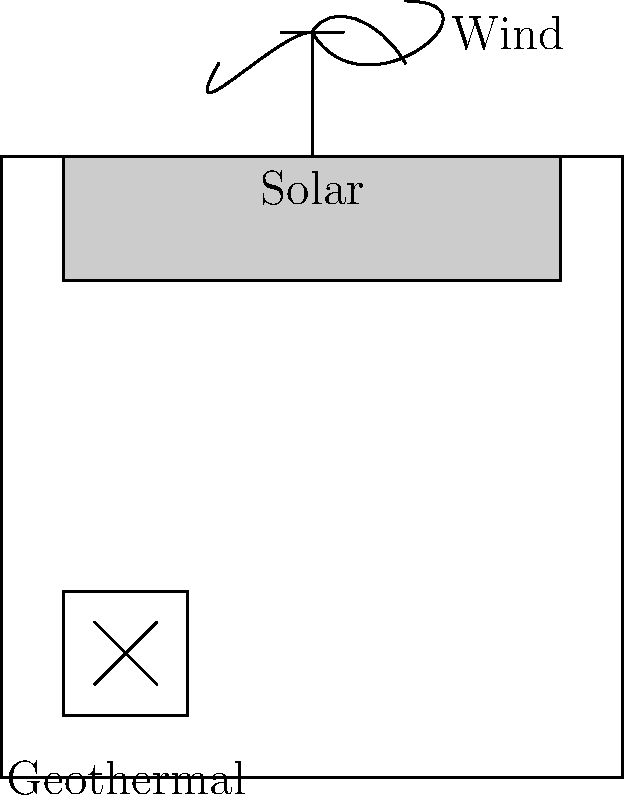As an environmentalist concerned with local energy efficiency, which renewable energy installation shown in the schematic drawing of a building would likely have the highest energy output in an urban setting, and why? To answer this question, we need to consider the characteristics of each renewable energy source shown in the schematic and their typical performance in urban environments:

1. Solar panels:
   - Positioned on the roof, maximizing exposure to sunlight
   - Effective in urban areas with minimal shading from other buildings
   - Consistent energy production during daylight hours
   - Efficiency typically ranges from 15-22% for commercial panels

2. Wind turbine:
   - Mounted on top of the building
   - Urban areas often have lower wind speeds and more turbulent airflow due to surrounding structures
   - Efficiency can vary greatly depending on wind conditions, typically 30-45% for small turbines

3. Geothermal system:
   - Installed underground, likely a ground source heat pump
   - Consistent performance regardless of weather conditions
   - Coefficient of Performance (COP) for heating can range from 3-5, meaning it produces 3-5 units of heat energy for every unit of electrical energy input

In an urban setting, solar panels are likely to have the highest energy output for several reasons:
   - Consistent and predictable energy production during daylight hours
   - Less affected by surrounding buildings compared to wind turbines
   - Scalable installation (can cover larger roof areas)
   - Improving technology with increasing efficiency

While geothermal systems are efficient, they primarily provide heating and cooling rather than electricity generation. Wind turbines in urban areas often underperform due to inconsistent and turbulent wind patterns.

Therefore, solar panels would likely be the most efficient and highest energy-producing installation in this urban setting.
Answer: Solar panels, due to consistent energy production and suitability for urban environments. 